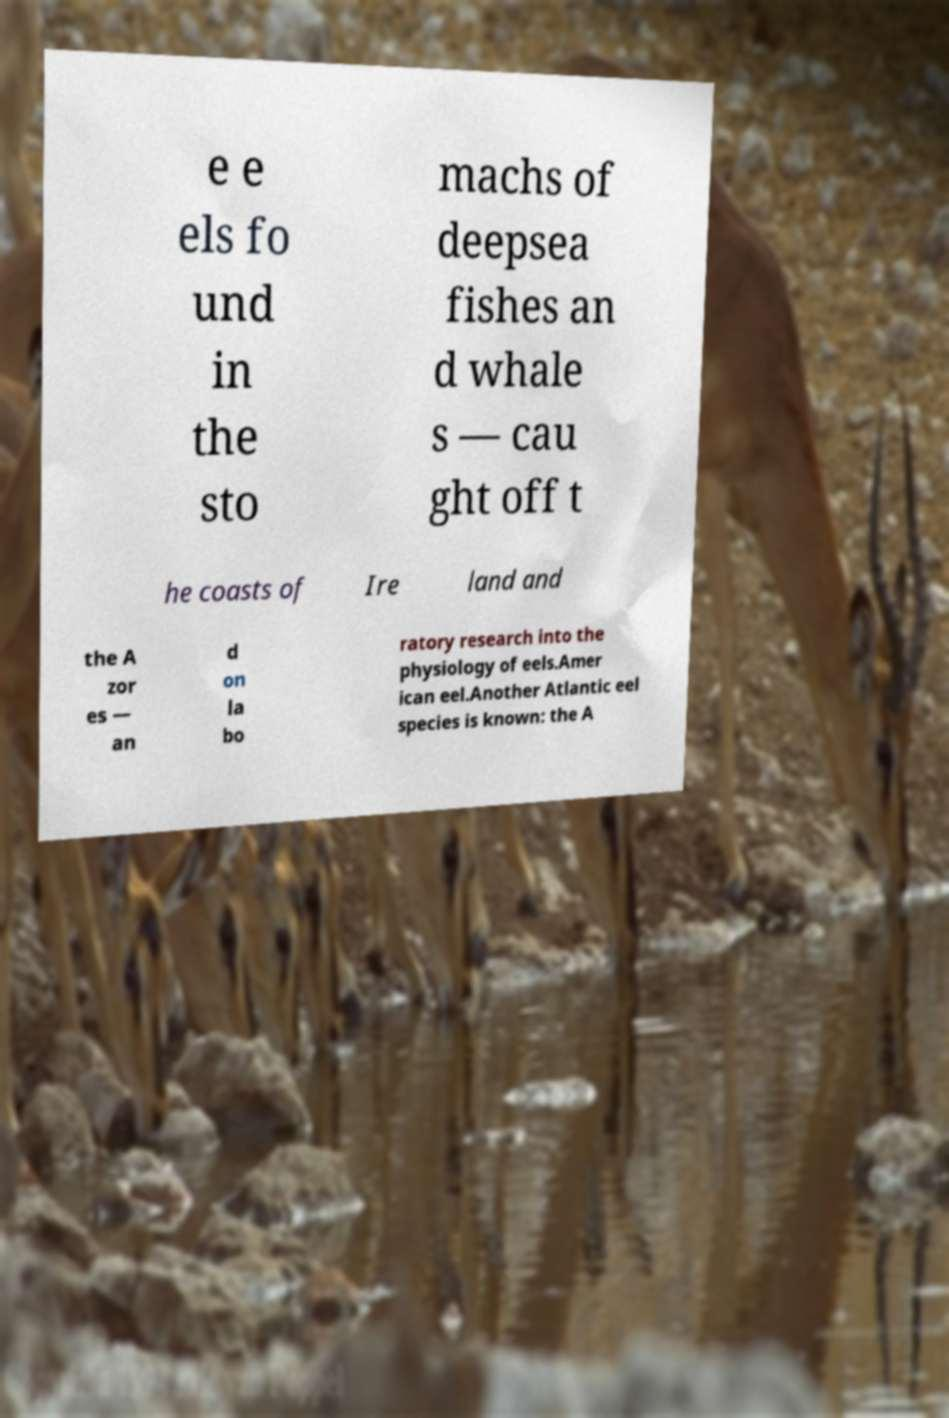There's text embedded in this image that I need extracted. Can you transcribe it verbatim? e e els fo und in the sto machs of deepsea fishes an d whale s — cau ght off t he coasts of Ire land and the A zor es — an d on la bo ratory research into the physiology of eels.Amer ican eel.Another Atlantic eel species is known: the A 